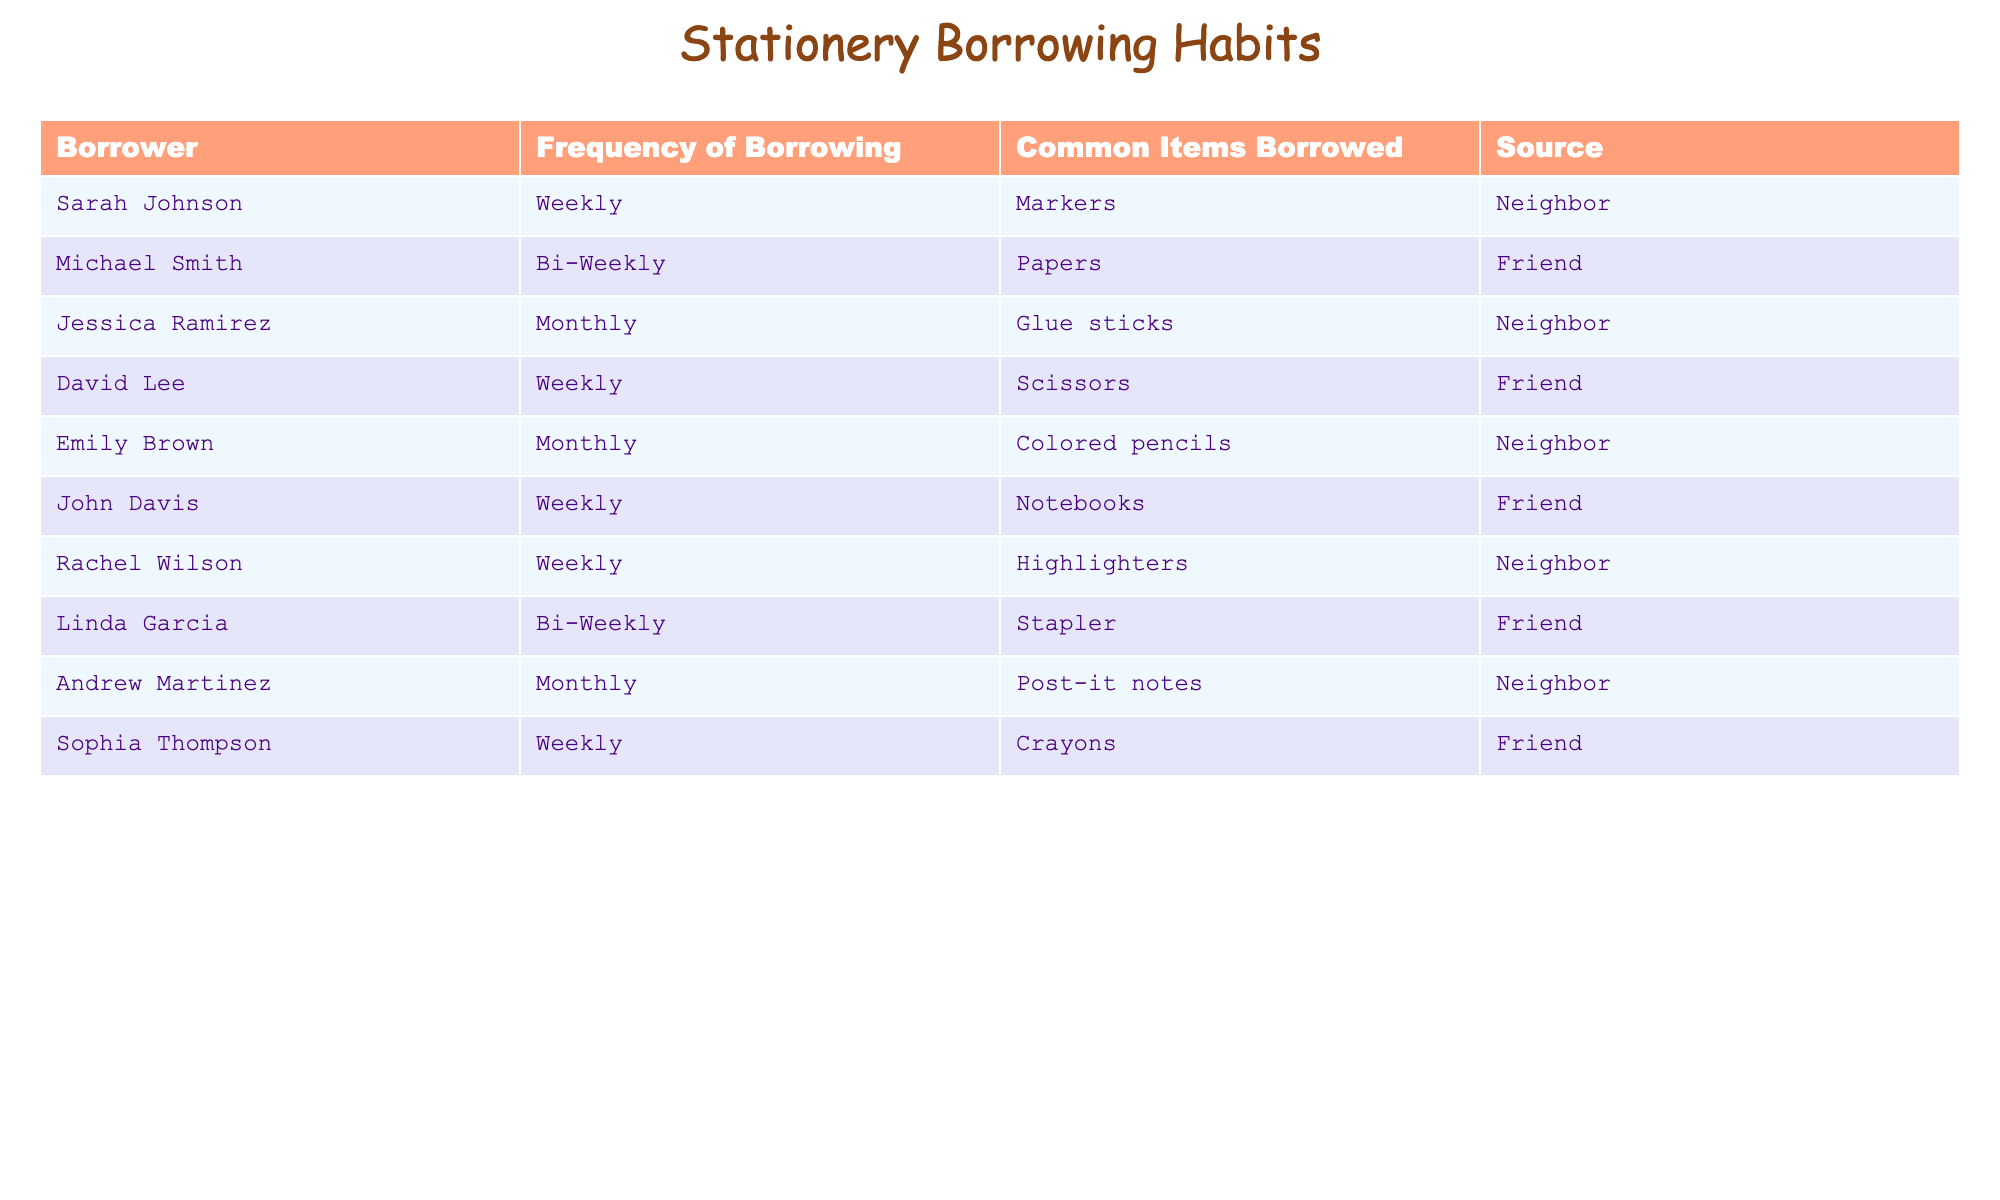What is the most common frequency of borrowing stationery among the individuals listed? By reviewing the 'Frequency of Borrowing' column, I can see that "Weekly" is mentioned six times, while the other frequencies, "Bi-Weekly" and "Monthly," are mentioned four times and three times, respectively. Therefore, "Weekly" is the most common frequency.
Answer: Weekly How many individuals borrowed stationery on a monthly basis? I can count the rows in the table where the 'Frequency of Borrowing' is "Monthly." There are three individuals listed with this frequency: Jessica Ramirez, Emily Brown, and Andrew Martinez.
Answer: 3 Is there anyone who borrows items bi-weekly? Looking at the table, I find that there are two individuals who borrow items bi-weekly: Michael Smith and Linda Garcia. Thus, the answer is yes.
Answer: Yes Which item do Sarah Johnson and David Lee borrow? In the 'Common Items Borrowed' column, I can find Sarah Johnson borrowing "Markers" and David Lee borrowing "Scissors." They borrow different items; thus, the answer is that they do not borrow the same item.
Answer: Different items What is the total number of stationery items borrowed by individuals who borrow weekly? To find the total number of items, I can list the common items borrowed by the six individuals who borrow weekly and count them: Markers, Scissors, Notebooks, Highlighters, and Crayons. Each person borrows one item, totaling five items.
Answer: 5 Which friend or neighbor is the most common source for borrowing? By reviewing the 'Source' column, I see that "Friend" is the choice for four individuals and "Neighbor" for six. Thus, "Neighbor" is more common as a source.
Answer: Neighbor Is there any individual who borrows crayons? I check the 'Common Items Borrowed' column and find that Sophia Thompson is the only person listed as borrowing "Crayons." Therefore, yes, there is someone who borrows crayons.
Answer: Yes What percentage of borrowers borrow items monthly? To calculate the percentage, I take the number of individuals who borrow monthly (3) and divide it by the total number of borrowers (10), then multiply by 100: (3/10) * 100 = 30%.
Answer: 30% 